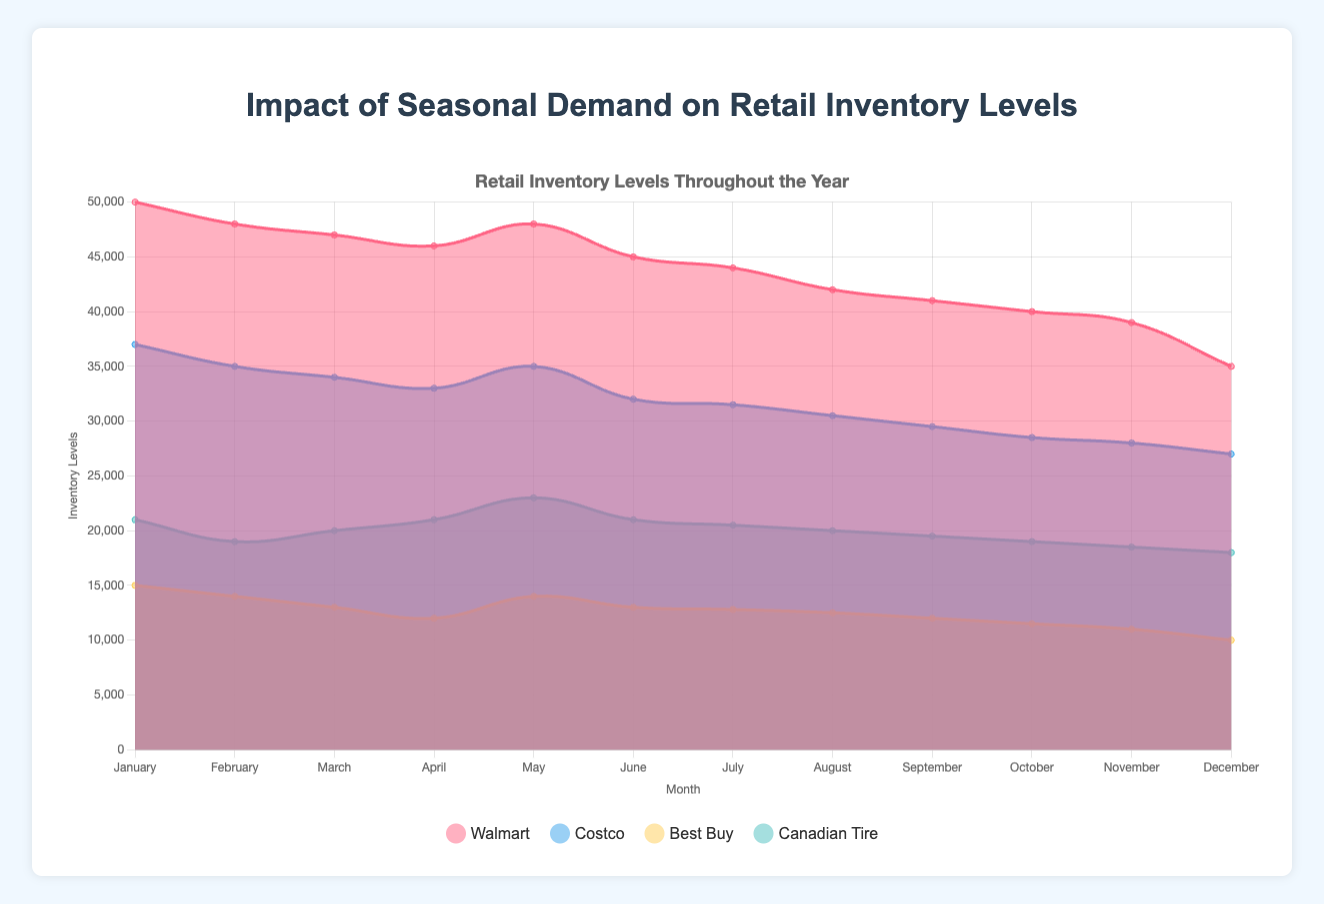How does Walmart's inventory level in December compare to November? To find out this, look at the inventory levels for Walmart in November and December. In November, it's 39,000, and in December, it's 35,000. Comparing the two values shows a decrease from November to December.
Answer: Decreased Which month showed the highest inventory levels for Best Buy? Look through the inventory levels for Best Buy in all months listed. Identify the month with the highest value. From the data, Best Buy has the highest inventory level in January (15,000).
Answer: January What's the average sales demand across all retailers in June? To calculate the average, sum up the sales demands for all retailers in June (Walmart: 42,000, Costco: 36,000, Best Buy: 15,000, Canadian Tire: 19,000). Then divide by the number of retailers (4). (42,000 + 36,000 + 15,000 + 19,000) / 4 = 112,000 / 4 = 28,000.
Answer: 28,000 How does Canadian Tire's inventory level fluctuate between July and September? Examine the inventory levels for Canadian Tire from July to September. July has 20,500 units, August has 20,000 units, and September has 19,500 units. This shows a decreasing trend.
Answer: Decreasing In which month did Costco have the smallest gap between inventory levels and sales demand? Find the differences between inventory levels and sales demand for each month for Costco. The smallest gap appears in April: Inventory = 33,000, Demand = 32,000, Gap = 1,000.
Answer: April Compare the sales demands between February and March for Best Buy. Check the sales demand for Best Buy in February (11,000) and March (12,000). Comparing these, March has a slightly higher sales demand than February.
Answer: March Which retailer had the most significant drop in inventory levels from January to December? Compare the inventory levels in January and December for all retailers. Walmart: 50,000 - 35,000 = 15,000, Costco: 37,000 - 27,000 = 10,000, Best Buy: 15,000 - 10,000 = 5,000, Canadian Tire: 21,000 - 18,000 = 3,000. Walmart had the largest drop (15,000 units).
Answer: Walmart How do the colors used in the chart distinguish between different retailers? The chart uses different colors for each retailer: Walmart (red), Costco (blue), Best Buy (yellow), and Canadian Tire (green). This helps visually differentiate them.
Answer: Red, Blue, Yellow, Green 